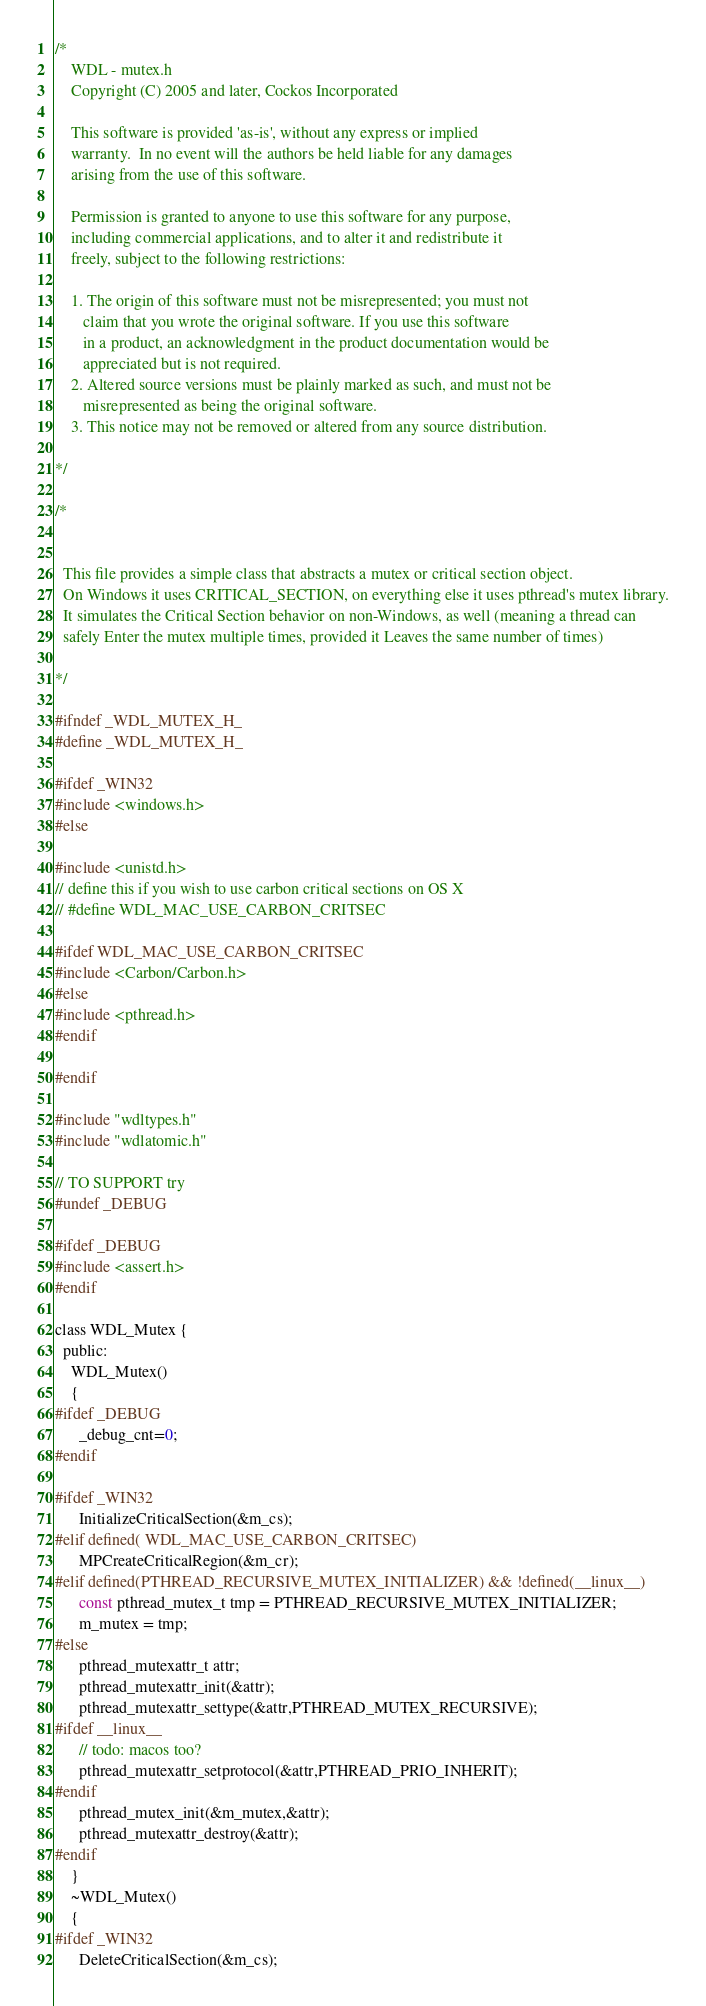<code> <loc_0><loc_0><loc_500><loc_500><_C_>/*
    WDL - mutex.h
    Copyright (C) 2005 and later, Cockos Incorporated
   
    This software is provided 'as-is', without any express or implied
    warranty.  In no event will the authors be held liable for any damages
    arising from the use of this software.

    Permission is granted to anyone to use this software for any purpose,
    including commercial applications, and to alter it and redistribute it
    freely, subject to the following restrictions:

    1. The origin of this software must not be misrepresented; you must not
       claim that you wrote the original software. If you use this software
       in a product, an acknowledgment in the product documentation would be
       appreciated but is not required.
    2. Altered source versions must be plainly marked as such, and must not be
       misrepresented as being the original software.
    3. This notice may not be removed or altered from any source distribution.
      
*/

/*


  This file provides a simple class that abstracts a mutex or critical section object.
  On Windows it uses CRITICAL_SECTION, on everything else it uses pthread's mutex library.
  It simulates the Critical Section behavior on non-Windows, as well (meaning a thread can 
  safely Enter the mutex multiple times, provided it Leaves the same number of times)
  
*/

#ifndef _WDL_MUTEX_H_
#define _WDL_MUTEX_H_

#ifdef _WIN32
#include <windows.h>
#else

#include <unistd.h>
// define this if you wish to use carbon critical sections on OS X
// #define WDL_MAC_USE_CARBON_CRITSEC

#ifdef WDL_MAC_USE_CARBON_CRITSEC
#include <Carbon/Carbon.h>
#else
#include <pthread.h>
#endif

#endif

#include "wdltypes.h"
#include "wdlatomic.h"

// TO SUPPORT try
#undef _DEBUG 

#ifdef _DEBUG
#include <assert.h>
#endif

class WDL_Mutex {
  public:
    WDL_Mutex() 
    {
#ifdef _DEBUG
      _debug_cnt=0;
#endif

#ifdef _WIN32
      InitializeCriticalSection(&m_cs);
#elif defined( WDL_MAC_USE_CARBON_CRITSEC)
      MPCreateCriticalRegion(&m_cr);
#elif defined(PTHREAD_RECURSIVE_MUTEX_INITIALIZER) && !defined(__linux__)
      const pthread_mutex_t tmp = PTHREAD_RECURSIVE_MUTEX_INITIALIZER;
      m_mutex = tmp;
#else
      pthread_mutexattr_t attr;
      pthread_mutexattr_init(&attr);
      pthread_mutexattr_settype(&attr,PTHREAD_MUTEX_RECURSIVE);
#ifdef __linux__
      // todo: macos too?
      pthread_mutexattr_setprotocol(&attr,PTHREAD_PRIO_INHERIT);
#endif
      pthread_mutex_init(&m_mutex,&attr);
      pthread_mutexattr_destroy(&attr);
#endif
    }
    ~WDL_Mutex()
    {
#ifdef _WIN32
      DeleteCriticalSection(&m_cs);</code> 